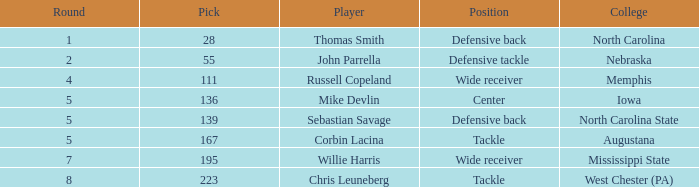What is the sum of Round with a Position that is center? 5.0. 